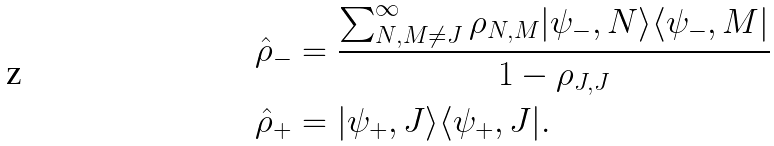<formula> <loc_0><loc_0><loc_500><loc_500>\hat { \rho } _ { - } & = \frac { \sum _ { N , M \neq J } ^ { \infty } \rho _ { N , M } | \psi _ { - } , N \rangle \langle \psi _ { - } , M | } { 1 - \rho _ { J , J } } \\ \hat { \rho } _ { + } & = | \psi _ { + } , J \rangle \langle \psi _ { + } , J | .</formula> 